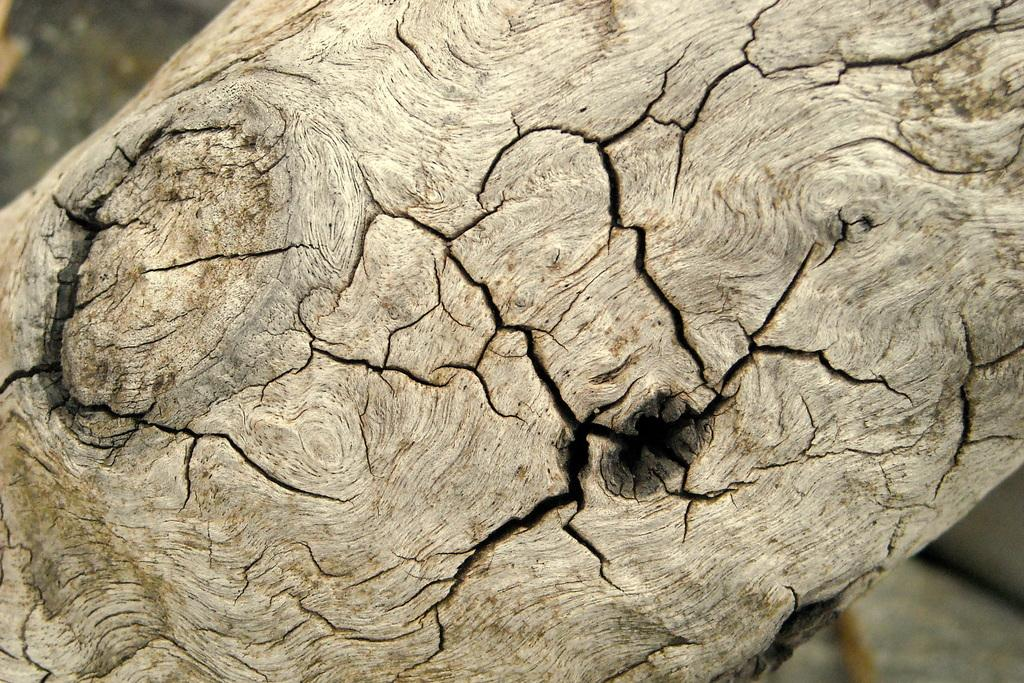What is the condition of the wood in the image? There are cracks on the wood in the image. Can you describe the background of the image? The background of the image is blurred. How many kittens are visible in the image? There are no kittens present in the image. 